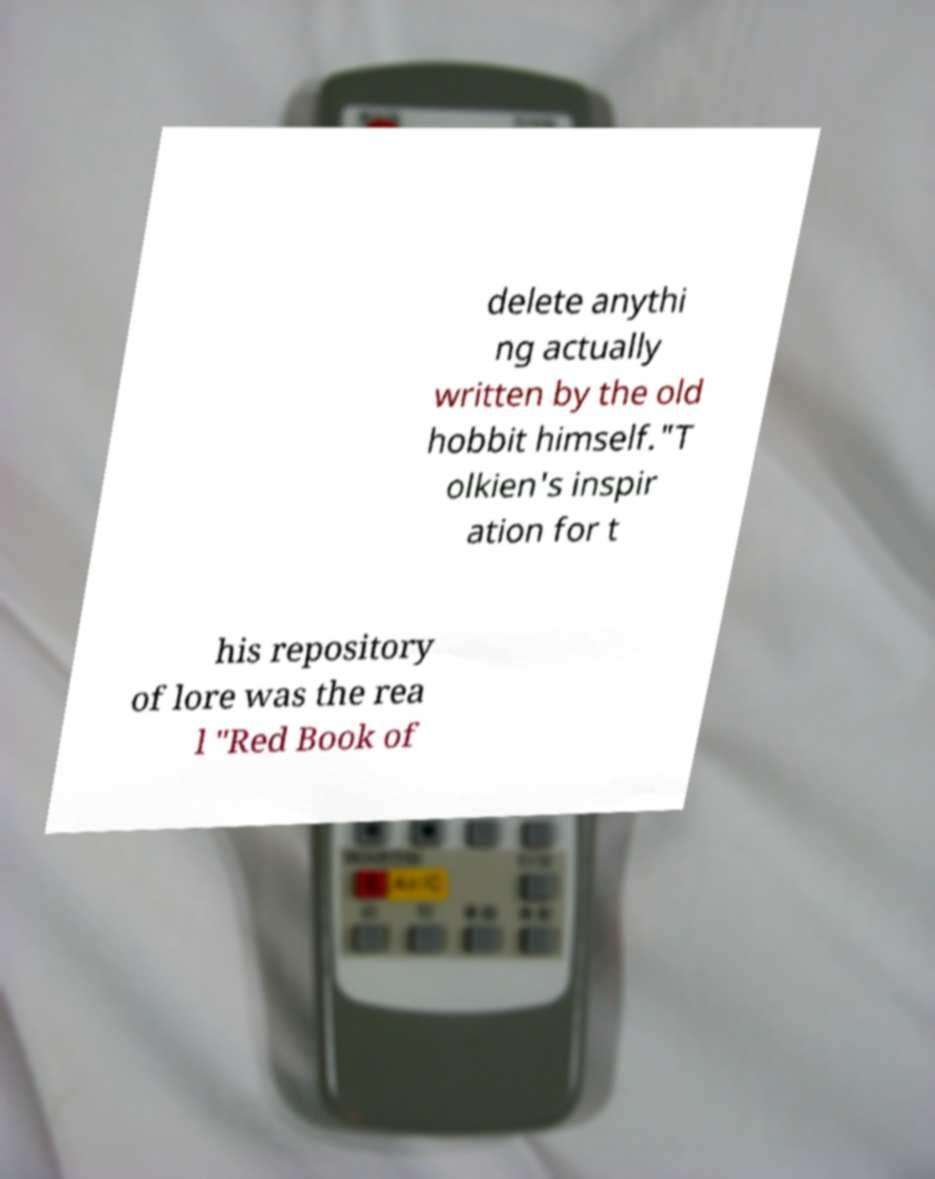Could you extract and type out the text from this image? delete anythi ng actually written by the old hobbit himself."T olkien's inspir ation for t his repository of lore was the rea l "Red Book of 